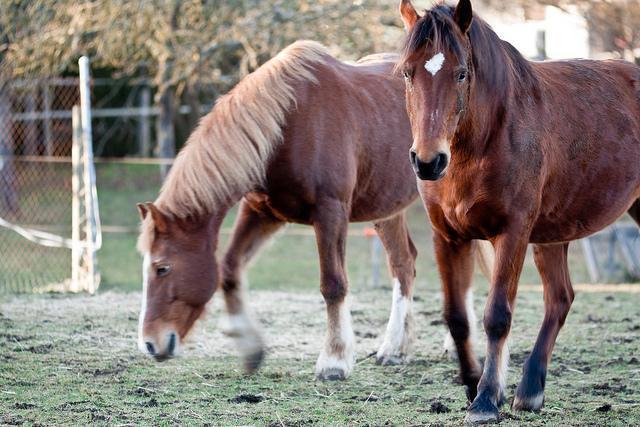How many horses can you see?
Give a very brief answer. 2. 